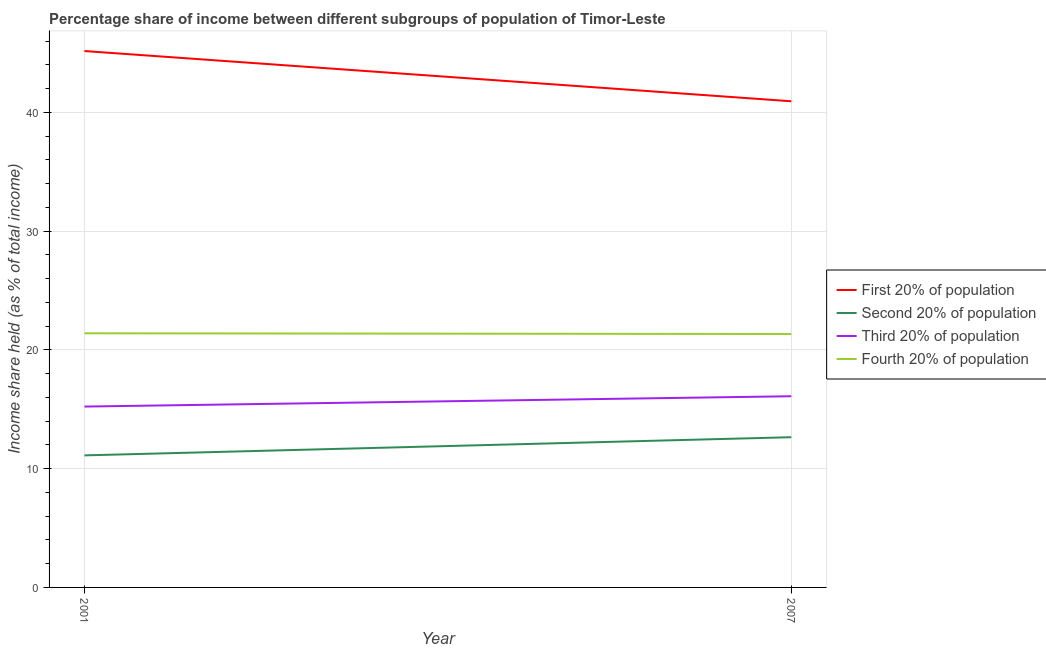How many different coloured lines are there?
Ensure brevity in your answer.  4. Does the line corresponding to share of the income held by fourth 20% of the population intersect with the line corresponding to share of the income held by third 20% of the population?
Provide a short and direct response. No. What is the share of the income held by first 20% of the population in 2007?
Offer a terse response. 40.94. Across all years, what is the maximum share of the income held by fourth 20% of the population?
Make the answer very short. 21.4. Across all years, what is the minimum share of the income held by fourth 20% of the population?
Offer a terse response. 21.34. In which year was the share of the income held by first 20% of the population minimum?
Provide a short and direct response. 2007. What is the total share of the income held by third 20% of the population in the graph?
Make the answer very short. 31.33. What is the difference between the share of the income held by fourth 20% of the population in 2001 and that in 2007?
Make the answer very short. 0.06. What is the difference between the share of the income held by first 20% of the population in 2001 and the share of the income held by third 20% of the population in 2007?
Give a very brief answer. 29.07. What is the average share of the income held by third 20% of the population per year?
Ensure brevity in your answer.  15.67. In the year 2001, what is the difference between the share of the income held by third 20% of the population and share of the income held by first 20% of the population?
Give a very brief answer. -29.94. What is the ratio of the share of the income held by fourth 20% of the population in 2001 to that in 2007?
Give a very brief answer. 1. Is it the case that in every year, the sum of the share of the income held by fourth 20% of the population and share of the income held by second 20% of the population is greater than the sum of share of the income held by third 20% of the population and share of the income held by first 20% of the population?
Your answer should be very brief. Yes. Is it the case that in every year, the sum of the share of the income held by first 20% of the population and share of the income held by second 20% of the population is greater than the share of the income held by third 20% of the population?
Your response must be concise. Yes. Is the share of the income held by second 20% of the population strictly greater than the share of the income held by fourth 20% of the population over the years?
Provide a succinct answer. No. Is the share of the income held by fourth 20% of the population strictly less than the share of the income held by second 20% of the population over the years?
Give a very brief answer. No. How many lines are there?
Provide a short and direct response. 4. What is the difference between two consecutive major ticks on the Y-axis?
Your answer should be very brief. 10. Does the graph contain any zero values?
Give a very brief answer. No. Does the graph contain grids?
Provide a succinct answer. Yes. How many legend labels are there?
Give a very brief answer. 4. How are the legend labels stacked?
Your response must be concise. Vertical. What is the title of the graph?
Your answer should be very brief. Percentage share of income between different subgroups of population of Timor-Leste. Does "Denmark" appear as one of the legend labels in the graph?
Make the answer very short. No. What is the label or title of the Y-axis?
Your answer should be very brief. Income share held (as % of total income). What is the Income share held (as % of total income) of First 20% of population in 2001?
Provide a short and direct response. 45.17. What is the Income share held (as % of total income) of Second 20% of population in 2001?
Your answer should be compact. 11.12. What is the Income share held (as % of total income) in Third 20% of population in 2001?
Provide a succinct answer. 15.23. What is the Income share held (as % of total income) of Fourth 20% of population in 2001?
Ensure brevity in your answer.  21.4. What is the Income share held (as % of total income) in First 20% of population in 2007?
Your response must be concise. 40.94. What is the Income share held (as % of total income) in Second 20% of population in 2007?
Offer a terse response. 12.65. What is the Income share held (as % of total income) in Fourth 20% of population in 2007?
Offer a very short reply. 21.34. Across all years, what is the maximum Income share held (as % of total income) of First 20% of population?
Provide a short and direct response. 45.17. Across all years, what is the maximum Income share held (as % of total income) of Second 20% of population?
Provide a succinct answer. 12.65. Across all years, what is the maximum Income share held (as % of total income) in Fourth 20% of population?
Provide a short and direct response. 21.4. Across all years, what is the minimum Income share held (as % of total income) of First 20% of population?
Provide a short and direct response. 40.94. Across all years, what is the minimum Income share held (as % of total income) in Second 20% of population?
Provide a short and direct response. 11.12. Across all years, what is the minimum Income share held (as % of total income) of Third 20% of population?
Provide a succinct answer. 15.23. Across all years, what is the minimum Income share held (as % of total income) of Fourth 20% of population?
Provide a short and direct response. 21.34. What is the total Income share held (as % of total income) of First 20% of population in the graph?
Your response must be concise. 86.11. What is the total Income share held (as % of total income) in Second 20% of population in the graph?
Offer a terse response. 23.77. What is the total Income share held (as % of total income) in Third 20% of population in the graph?
Give a very brief answer. 31.33. What is the total Income share held (as % of total income) in Fourth 20% of population in the graph?
Make the answer very short. 42.74. What is the difference between the Income share held (as % of total income) in First 20% of population in 2001 and that in 2007?
Give a very brief answer. 4.23. What is the difference between the Income share held (as % of total income) in Second 20% of population in 2001 and that in 2007?
Your answer should be compact. -1.53. What is the difference between the Income share held (as % of total income) of Third 20% of population in 2001 and that in 2007?
Your response must be concise. -0.87. What is the difference between the Income share held (as % of total income) of First 20% of population in 2001 and the Income share held (as % of total income) of Second 20% of population in 2007?
Offer a very short reply. 32.52. What is the difference between the Income share held (as % of total income) in First 20% of population in 2001 and the Income share held (as % of total income) in Third 20% of population in 2007?
Offer a terse response. 29.07. What is the difference between the Income share held (as % of total income) in First 20% of population in 2001 and the Income share held (as % of total income) in Fourth 20% of population in 2007?
Make the answer very short. 23.83. What is the difference between the Income share held (as % of total income) of Second 20% of population in 2001 and the Income share held (as % of total income) of Third 20% of population in 2007?
Provide a short and direct response. -4.98. What is the difference between the Income share held (as % of total income) in Second 20% of population in 2001 and the Income share held (as % of total income) in Fourth 20% of population in 2007?
Keep it short and to the point. -10.22. What is the difference between the Income share held (as % of total income) of Third 20% of population in 2001 and the Income share held (as % of total income) of Fourth 20% of population in 2007?
Give a very brief answer. -6.11. What is the average Income share held (as % of total income) of First 20% of population per year?
Provide a succinct answer. 43.05. What is the average Income share held (as % of total income) of Second 20% of population per year?
Make the answer very short. 11.88. What is the average Income share held (as % of total income) of Third 20% of population per year?
Keep it short and to the point. 15.66. What is the average Income share held (as % of total income) of Fourth 20% of population per year?
Provide a succinct answer. 21.37. In the year 2001, what is the difference between the Income share held (as % of total income) in First 20% of population and Income share held (as % of total income) in Second 20% of population?
Offer a terse response. 34.05. In the year 2001, what is the difference between the Income share held (as % of total income) of First 20% of population and Income share held (as % of total income) of Third 20% of population?
Offer a very short reply. 29.94. In the year 2001, what is the difference between the Income share held (as % of total income) of First 20% of population and Income share held (as % of total income) of Fourth 20% of population?
Keep it short and to the point. 23.77. In the year 2001, what is the difference between the Income share held (as % of total income) of Second 20% of population and Income share held (as % of total income) of Third 20% of population?
Provide a short and direct response. -4.11. In the year 2001, what is the difference between the Income share held (as % of total income) in Second 20% of population and Income share held (as % of total income) in Fourth 20% of population?
Offer a very short reply. -10.28. In the year 2001, what is the difference between the Income share held (as % of total income) of Third 20% of population and Income share held (as % of total income) of Fourth 20% of population?
Ensure brevity in your answer.  -6.17. In the year 2007, what is the difference between the Income share held (as % of total income) of First 20% of population and Income share held (as % of total income) of Second 20% of population?
Keep it short and to the point. 28.29. In the year 2007, what is the difference between the Income share held (as % of total income) of First 20% of population and Income share held (as % of total income) of Third 20% of population?
Offer a terse response. 24.84. In the year 2007, what is the difference between the Income share held (as % of total income) of First 20% of population and Income share held (as % of total income) of Fourth 20% of population?
Offer a terse response. 19.6. In the year 2007, what is the difference between the Income share held (as % of total income) of Second 20% of population and Income share held (as % of total income) of Third 20% of population?
Offer a terse response. -3.45. In the year 2007, what is the difference between the Income share held (as % of total income) in Second 20% of population and Income share held (as % of total income) in Fourth 20% of population?
Keep it short and to the point. -8.69. In the year 2007, what is the difference between the Income share held (as % of total income) of Third 20% of population and Income share held (as % of total income) of Fourth 20% of population?
Make the answer very short. -5.24. What is the ratio of the Income share held (as % of total income) in First 20% of population in 2001 to that in 2007?
Your answer should be very brief. 1.1. What is the ratio of the Income share held (as % of total income) in Second 20% of population in 2001 to that in 2007?
Keep it short and to the point. 0.88. What is the ratio of the Income share held (as % of total income) in Third 20% of population in 2001 to that in 2007?
Make the answer very short. 0.95. What is the difference between the highest and the second highest Income share held (as % of total income) of First 20% of population?
Offer a terse response. 4.23. What is the difference between the highest and the second highest Income share held (as % of total income) in Second 20% of population?
Provide a succinct answer. 1.53. What is the difference between the highest and the second highest Income share held (as % of total income) in Third 20% of population?
Offer a very short reply. 0.87. What is the difference between the highest and the second highest Income share held (as % of total income) in Fourth 20% of population?
Your answer should be very brief. 0.06. What is the difference between the highest and the lowest Income share held (as % of total income) of First 20% of population?
Give a very brief answer. 4.23. What is the difference between the highest and the lowest Income share held (as % of total income) in Second 20% of population?
Give a very brief answer. 1.53. What is the difference between the highest and the lowest Income share held (as % of total income) in Third 20% of population?
Give a very brief answer. 0.87. 